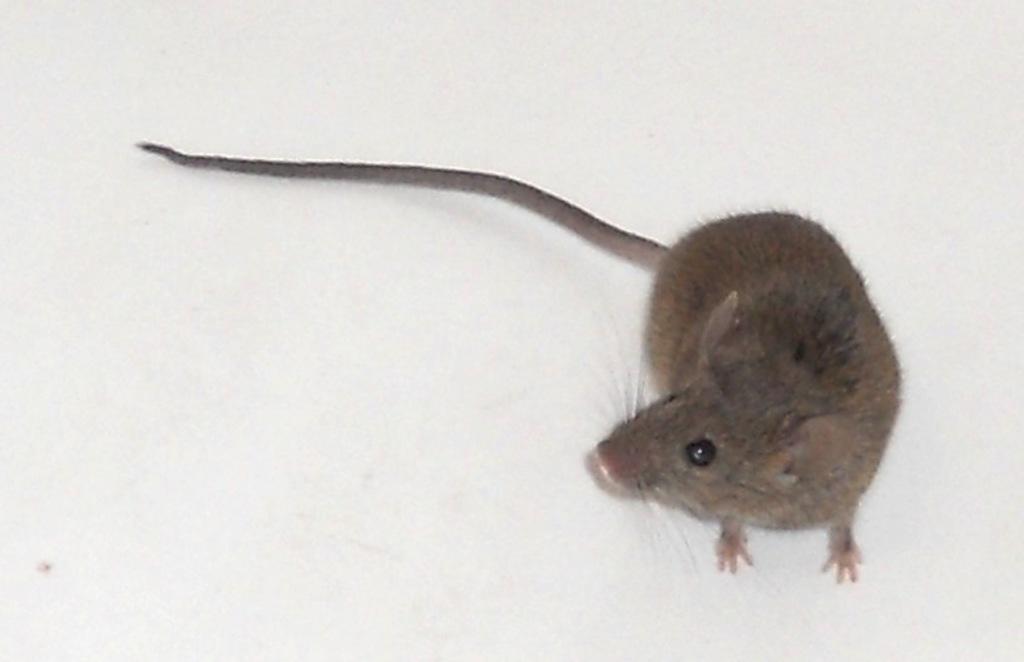Could you give a brief overview of what you see in this image? In this image we can see a rat. There is a white background in the image. 